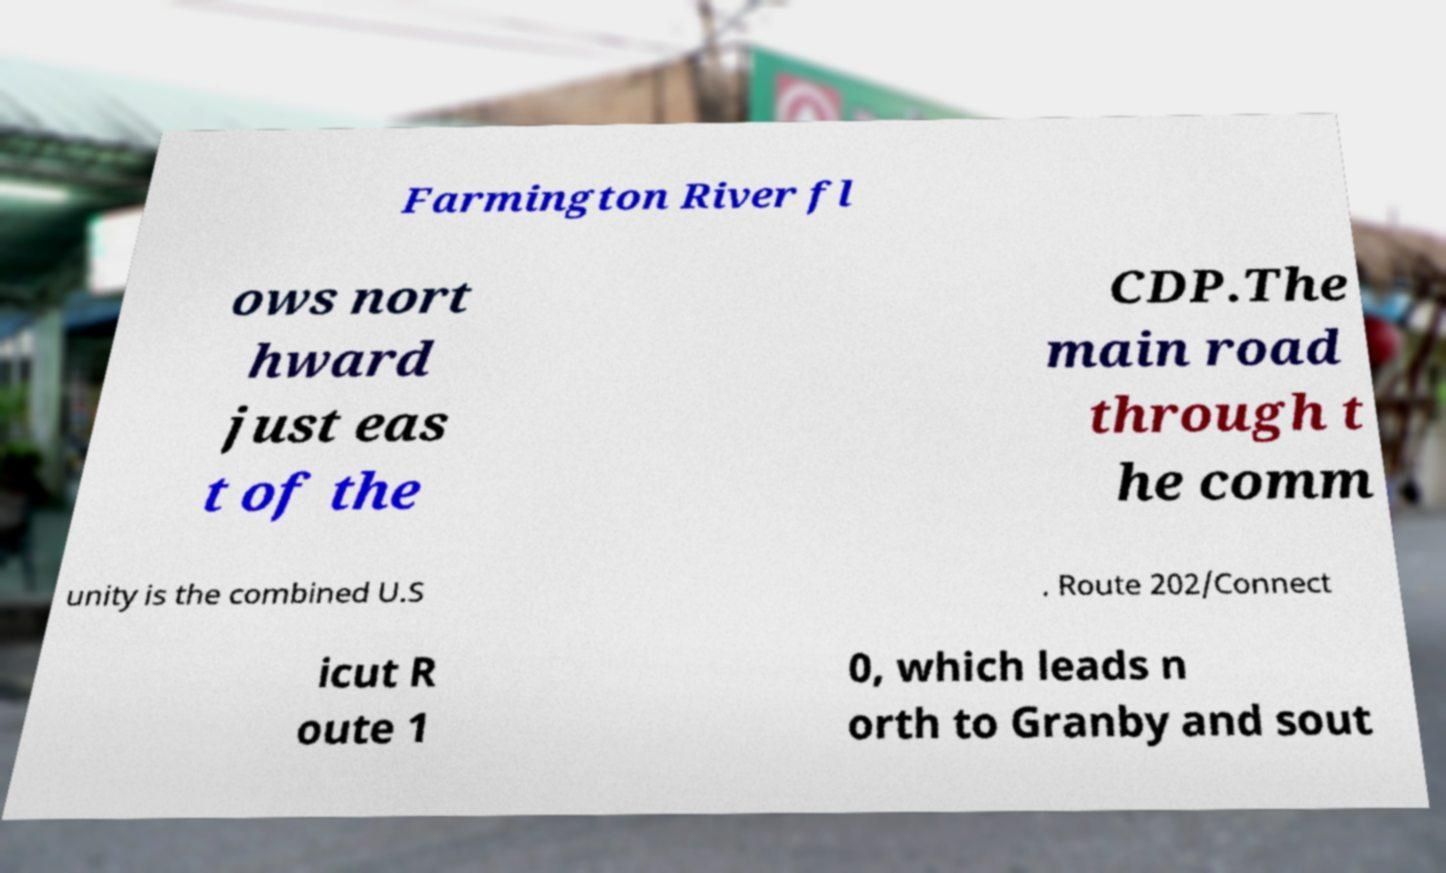What messages or text are displayed in this image? I need them in a readable, typed format. Farmington River fl ows nort hward just eas t of the CDP.The main road through t he comm unity is the combined U.S . Route 202/Connect icut R oute 1 0, which leads n orth to Granby and sout 